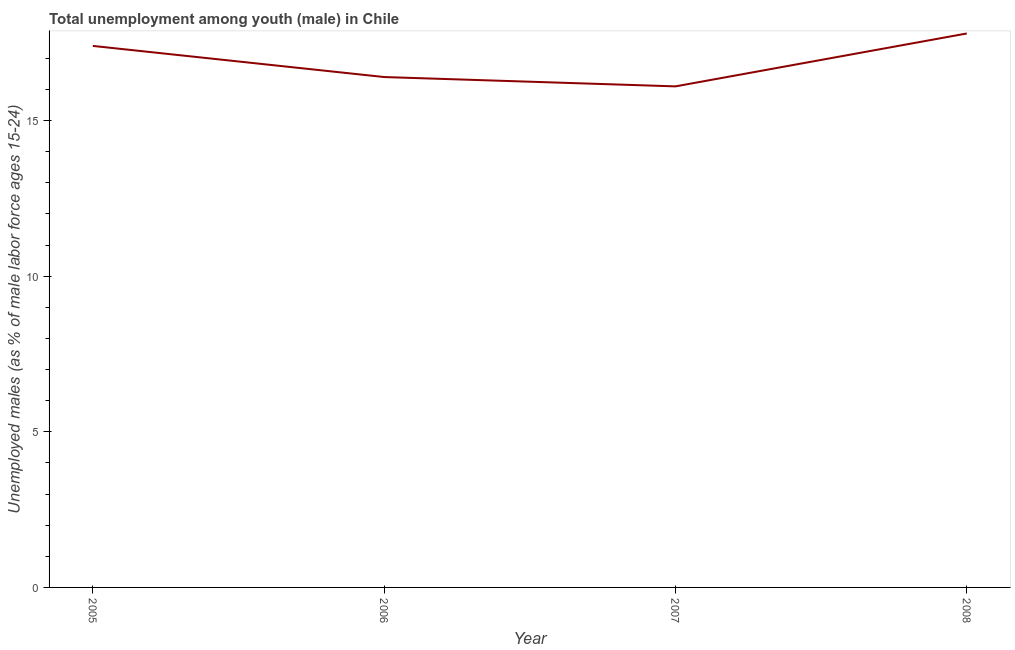What is the unemployed male youth population in 2006?
Give a very brief answer. 16.4. Across all years, what is the maximum unemployed male youth population?
Provide a succinct answer. 17.8. Across all years, what is the minimum unemployed male youth population?
Offer a very short reply. 16.1. In which year was the unemployed male youth population maximum?
Give a very brief answer. 2008. What is the sum of the unemployed male youth population?
Ensure brevity in your answer.  67.7. What is the difference between the unemployed male youth population in 2006 and 2008?
Ensure brevity in your answer.  -1.4. What is the average unemployed male youth population per year?
Provide a succinct answer. 16.92. What is the median unemployed male youth population?
Provide a short and direct response. 16.9. In how many years, is the unemployed male youth population greater than 14 %?
Your answer should be compact. 4. What is the ratio of the unemployed male youth population in 2005 to that in 2008?
Provide a short and direct response. 0.98. Is the unemployed male youth population in 2005 less than that in 2006?
Your response must be concise. No. What is the difference between the highest and the second highest unemployed male youth population?
Make the answer very short. 0.4. Is the sum of the unemployed male youth population in 2007 and 2008 greater than the maximum unemployed male youth population across all years?
Provide a short and direct response. Yes. What is the difference between the highest and the lowest unemployed male youth population?
Provide a short and direct response. 1.7. In how many years, is the unemployed male youth population greater than the average unemployed male youth population taken over all years?
Keep it short and to the point. 2. How many lines are there?
Provide a succinct answer. 1. How many years are there in the graph?
Your answer should be compact. 4. What is the difference between two consecutive major ticks on the Y-axis?
Make the answer very short. 5. Are the values on the major ticks of Y-axis written in scientific E-notation?
Provide a short and direct response. No. Does the graph contain grids?
Your response must be concise. No. What is the title of the graph?
Offer a very short reply. Total unemployment among youth (male) in Chile. What is the label or title of the Y-axis?
Keep it short and to the point. Unemployed males (as % of male labor force ages 15-24). What is the Unemployed males (as % of male labor force ages 15-24) in 2005?
Offer a very short reply. 17.4. What is the Unemployed males (as % of male labor force ages 15-24) of 2006?
Offer a terse response. 16.4. What is the Unemployed males (as % of male labor force ages 15-24) of 2007?
Provide a short and direct response. 16.1. What is the Unemployed males (as % of male labor force ages 15-24) in 2008?
Your response must be concise. 17.8. What is the difference between the Unemployed males (as % of male labor force ages 15-24) in 2005 and 2006?
Your response must be concise. 1. What is the difference between the Unemployed males (as % of male labor force ages 15-24) in 2005 and 2007?
Your response must be concise. 1.3. What is the ratio of the Unemployed males (as % of male labor force ages 15-24) in 2005 to that in 2006?
Your answer should be compact. 1.06. What is the ratio of the Unemployed males (as % of male labor force ages 15-24) in 2005 to that in 2007?
Provide a succinct answer. 1.08. What is the ratio of the Unemployed males (as % of male labor force ages 15-24) in 2006 to that in 2007?
Provide a succinct answer. 1.02. What is the ratio of the Unemployed males (as % of male labor force ages 15-24) in 2006 to that in 2008?
Your response must be concise. 0.92. What is the ratio of the Unemployed males (as % of male labor force ages 15-24) in 2007 to that in 2008?
Your response must be concise. 0.9. 